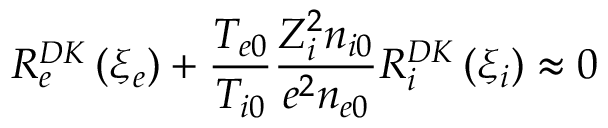Convert formula to latex. <formula><loc_0><loc_0><loc_500><loc_500>R _ { e } ^ { D K } \left ( \xi _ { e } \right ) + \frac { T _ { e 0 } } { T _ { i 0 } } \frac { Z _ { i } ^ { 2 } n _ { i 0 } } { e ^ { 2 } n _ { e 0 } } R _ { i } ^ { D K } \left ( \xi _ { i } \right ) \approx 0</formula> 